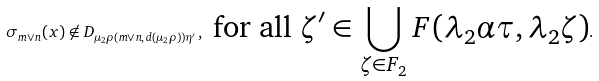<formula> <loc_0><loc_0><loc_500><loc_500>\sigma _ { m \vee n } ( x ) \not \in D _ { \mu _ { 2 } \rho ( m \vee n , d ( \mu _ { 2 } \rho ) ) \eta ^ { \prime } } , \text { for all $\zeta^{\prime}\in \bigcup_{\zeta\in F_{2}}F(\lambda_{2}\alpha\tau,\lambda_{2}\zeta)$} .</formula> 